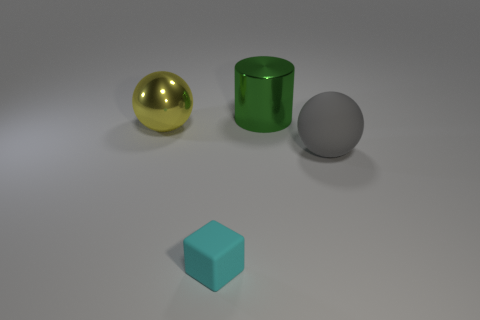What number of big green objects are to the left of the large metallic object to the right of the ball left of the gray sphere?
Give a very brief answer. 0. There is a ball that is to the left of the large green thing; is it the same size as the sphere right of the big green metal cylinder?
Offer a terse response. Yes. What is the material of the big gray thing in front of the big sphere to the left of the cyan cube?
Ensure brevity in your answer.  Rubber. How many objects are either objects to the right of the tiny cyan matte cube or large cyan metallic cylinders?
Provide a short and direct response. 2. Are there an equal number of cylinders that are in front of the small cyan matte thing and big green cylinders in front of the gray rubber thing?
Make the answer very short. Yes. The sphere on the left side of the large ball that is to the right of the shiny object in front of the large green thing is made of what material?
Offer a terse response. Metal. How big is the object that is behind the gray matte ball and to the left of the large green metallic cylinder?
Offer a terse response. Large. Do the large yellow metallic object and the tiny thing have the same shape?
Provide a succinct answer. No. The thing that is the same material as the large cylinder is what shape?
Your response must be concise. Sphere. What number of small things are either cyan objects or shiny things?
Offer a very short reply. 1. 